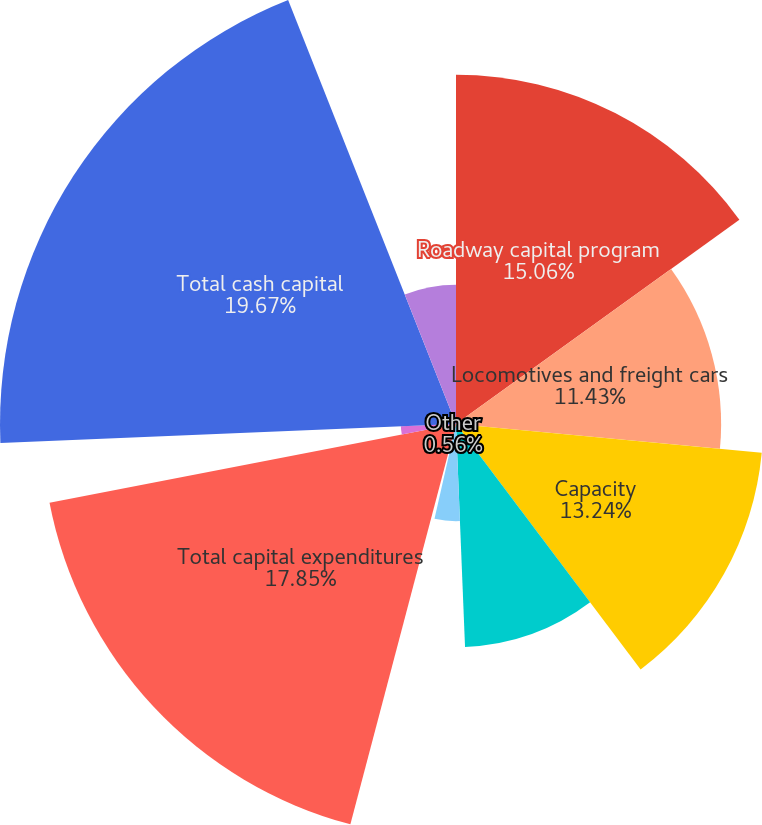Convert chart to OTSL. <chart><loc_0><loc_0><loc_500><loc_500><pie_chart><fcel>Roadway capital program<fcel>Locomotives and freight cars<fcel>Capacity<fcel>Positive train control<fcel>Information technology<fcel>Other<fcel>Total capital expenditures<fcel>Change in capital accruals<fcel>Total cash capital<fcel>Purchase or replacement of<nl><fcel>15.06%<fcel>11.43%<fcel>13.24%<fcel>9.62%<fcel>4.19%<fcel>0.56%<fcel>17.85%<fcel>2.38%<fcel>19.66%<fcel>6.0%<nl></chart> 